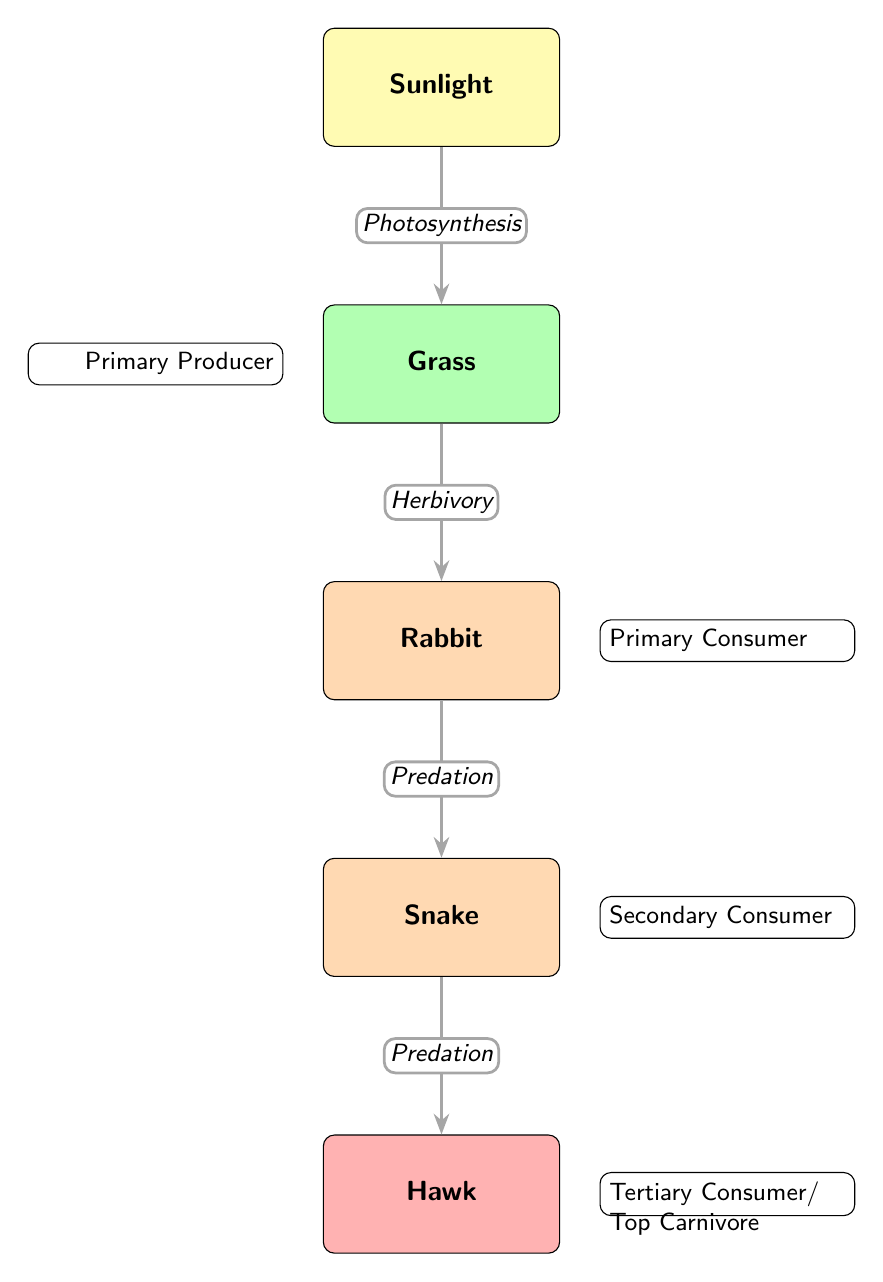What is the primary producer in this food web? The diagram shows "Grass" as the primary producer, as it is positioned directly below "Sunlight," which provides energy through photosynthesis.
Answer: Grass How many nodes are in the diagram? By counting the different entities depicted in the diagram, there are five nodes: Sunlight, Grass, Rabbit, Snake, and Hawk.
Answer: 5 What type of consumer is the Rabbit? The Rabbit is classified as a primary consumer in the diagram, as it feeds on the primary producer, which is Grass.
Answer: Primary Consumer What relationship does the Snake have with the Rabbit? The diagram indicates that the Snake has a "Predation" relationship with the Rabbit, meaning the Snake preys on the Rabbit for energy.
Answer: Predation What hierarchy level does the Hawk represent? The Hawk is labeled as a tertiary consumer or top carnivore in the diagram, indicating it is at the highest level of the food web, preying on the Snake.
Answer: Tertiary Consumer/ Top Carnivore Which process links sunlight to Grass? The arrow pointing from Sunlight to Grass is labeled "Photosynthesis," indicating that this is the process that converts sunlight into energy for the Grass.
Answer: Photosynthesis How many edges are there in the food web? By counting the arrows that connect the nodes, there are four edges: Sunlight to Grass, Grass to Rabbit, Rabbit to Snake, and Snake to Hawk.
Answer: 4 Which consumer feeds directly on the primary producer? The Rabbit directly feeds on the primary producer, which is Grass, represented by the arrow going from Grass to Rabbit.
Answer: Rabbit What type of consumer is the Snake? The Snake is identified as a secondary consumer since it preys on the primary consumer, Rabbit, for energy.
Answer: Secondary Consumer What flow direction shows energy transfer from Rabbit to Snake? The arrow from Rabbit to Snake represents the flow of energy during the "Predation" process, indicating the energy transfer from the Rabbit to the Snake.
Answer: Predation 